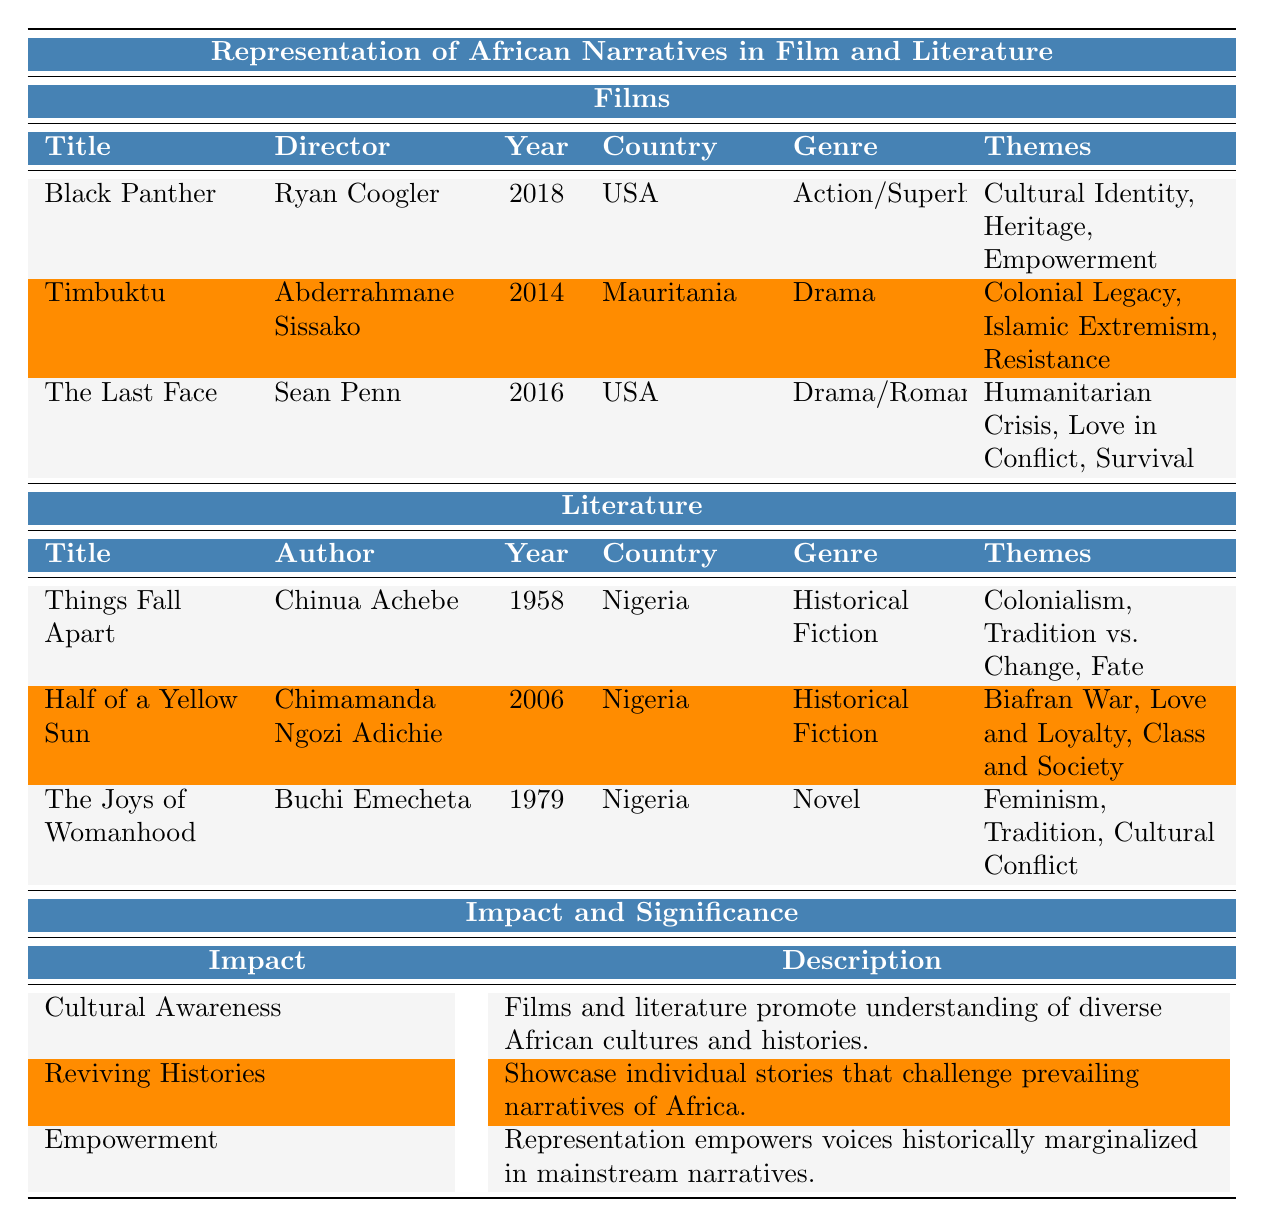What is the title of the film directed by Ryan Coogler? The table lists the films along with their directors. By looking under the 'Director' column, we find that "Black Panther" is directed by Ryan Coogler.
Answer: Black Panther Which film addresses themes of Islamic extremism? By reviewing the 'Themes' column for each film, we see that "Timbuktu" includes the theme of Islamic extremism.
Answer: Timbuktu How many films listed are from the USA? The table shows three films. Upon counting the films in the USA (Black Panther and The Last Face), there are two films from this country.
Answer: 2 What themes are associated with "Things Fall Apart"? Under the 'Themes' for the literature section, "Things Fall Apart" is associated with Colonialism, Tradition vs. Change, and Fate.
Answer: Colonialism, Tradition vs. Change, Fate Is "Half of a Yellow Sun" a historical fiction novel? Checking the genre for "Half of a Yellow Sun" in the literature section confirms that it is categorized as Historical Fiction.
Answer: Yes What is the year of release for the film "The Last Face"? The table indicates that "The Last Face" was released in the year 2016.
Answer: 2016 Which novel focuses on themes of feminism? Examining the 'Themes' in the literature section, "The Joys of Womanhood" prominently addresses feminism.
Answer: The Joys of Womanhood List the three themes from the film "Black Panther." Looking at the 'Themes' column, "Black Panther" encompasses Cultural Identity, Heritage, and Empowerment.
Answer: Cultural Identity, Heritage, Empowerment Which country is associated with the author Chinua Achebe? The data in the literature section shows that Chinua Achebe is from Nigeria.
Answer: Nigeria How does the representation in films and literature contribute to cultural awareness? According to the Impact and Significance section, films and literature promote understanding of diverse African cultures and histories, hence enhancing cultural awareness.
Answer: They promote understanding of diverse cultures and histories How many Nigerian authors are listed in the literature section? In the literature section, there are three titles authored by Nigerian authors (Chinua Achebe, Chimamanda Ngozi Adichie, and Buchi Emecheta), indicating a total of three.
Answer: 3 What are the main impacts listed in the representation of African narratives? The table outlines three impacts: Cultural Awareness, Reviving Histories, and Empowerment.
Answer: Cultural Awareness, Reviving Histories, Empowerment Are there any films about humanitarian crisis? By looking under the 'Themes' column for films listed, "The Last Face" explicitly addresses humanitarian crisis.
Answer: Yes Compare the genres of the films with the ones of the literature titles. The films include Action/Superhero and Drama genres, while the literature titles are primarily Historical Fiction and Novel.
Answer: Different genres exist with films in Action/Superhero and Drama vs. Literature in Historical Fiction and Novel Which film and author both address themes related to tradition and change? "Black Panther" touches on themes related to cultural identity (tradition), while "Things Fall Apart" discusses Tradition vs. Change explicitly.
Answer: Black Panther and Things Fall Apart 